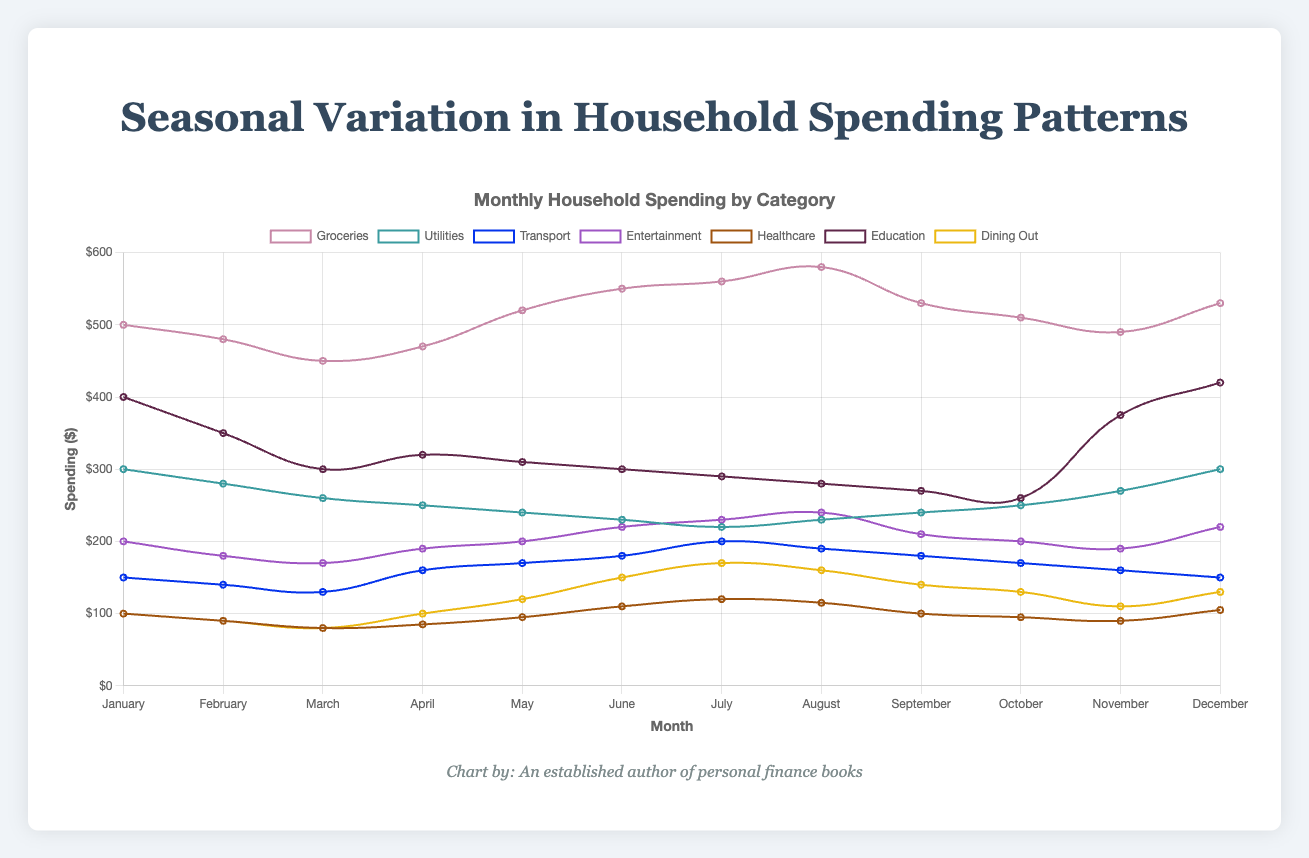Which category saw the highest spending in July? To determine the category with the highest spending in July, we need to compare the spending amounts for each category in that month. July spending amounts are: Groceries ($560), Utilities ($220), Transport ($200), Entertainment ($230), Healthcare ($120), Education ($290), Dining Out ($170). The highest value is $560 for Groceries.
Answer: Groceries How does the spending on Utilities in December compare to that in June? We need to compare the values listed for Utilities spending in December and June. The spending on Utilities in December is $300, while in June it is $230. The comparison shows that the spending on Utilities in December is higher.
Answer: Higher What is the trend in Healthcare spending throughout the year? To identify the trend, observe the Healthcare spending data points from January to December: $100, $90, $80, $85, $95, $110, $120, $115, $100, $95, $90, $105. Healthcare spending generally starts low, increases towards the middle of the year, peaks in July, and then fluctuates slightly toward the end of the year.
Answer: Increases and then fluctuates How much more was spent on Entertainment in August compared to February? Look at the spending values for Entertainment in August and February. In August it is $240, and in February it is $180. The difference is $240 - $180, which is $60.
Answer: $60 What is the average monthly spending on Groceries? Sum the monthly spending on Groceries and divide by 12. The spending amounts are: 500, 480, 450, 470, 520, 550, 560, 580, 530, 510, 490, 530. The total sum is 6170. The average is 6170 / 12, which is approximately $514.17.
Answer: $514.17 In which month was the spending on Transport the lowest, and what was the amount? Examine the spending values for Transport across all months: 
January ($150), February ($140), March ($130), April ($160), May ($170), June ($180), July ($200), August ($190), September ($180), October ($170), November ($160), December ($150). The lowest value is $130 in March.
Answer: March, $130 What is the total annual spending on Dining Out? Sum the monthly spending on Dining Out. The spending amounts are: 100, 90, 80, 100, 120, 150, 170, 160, 140, 130, 110, 130. The total sum is 1480.
Answer: $1480 